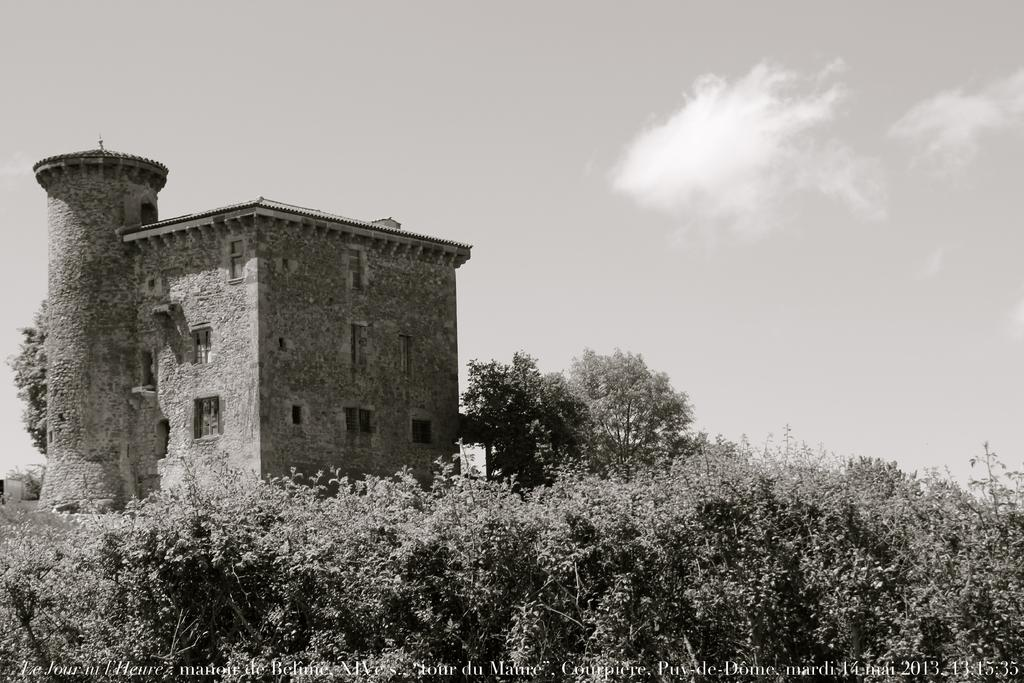What type of natural elements can be seen in the image? There are trees in the image. What type of man-made structure is visible in the background? There is a building in the background of the image. What part of the natural environment is visible in the image? The sky is visible in the background of the image. What is the color scheme of the image? The image is in black and white. What type of thread is being used to sew the building in the image? There is no thread or sewing involved in the image; it features trees, a building, and the sky in black and white. How many drops of water can be seen falling from the sky in the image? There are no drops of water visible in the image; it is in black and white and does not depict any rain or water droplets. 